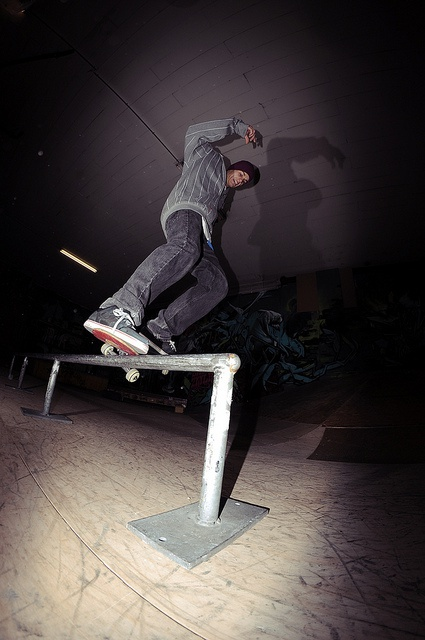Describe the objects in this image and their specific colors. I can see people in black, gray, and darkgray tones, skateboard in black, brown, darkgray, beige, and gray tones, and skateboard in black, darkgray, and gray tones in this image. 